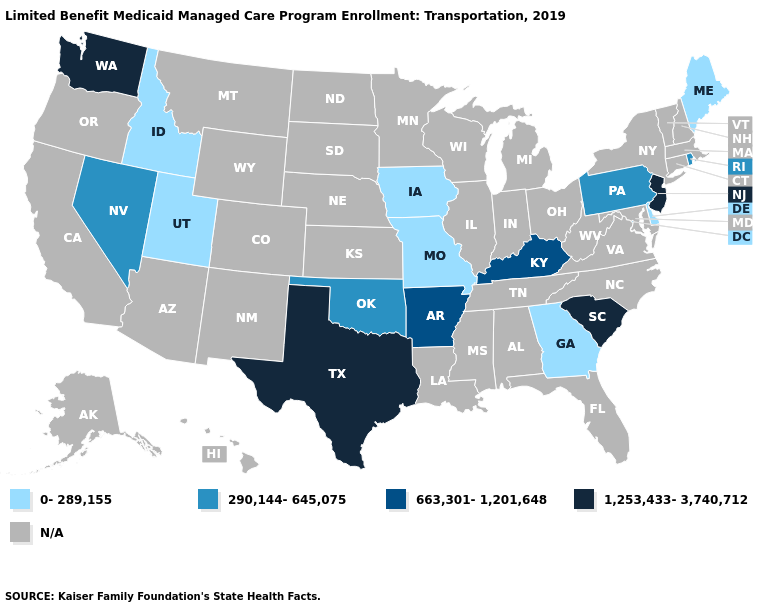Which states have the highest value in the USA?
Keep it brief. New Jersey, South Carolina, Texas, Washington. What is the value of Tennessee?
Keep it brief. N/A. Which states have the lowest value in the USA?
Keep it brief. Delaware, Georgia, Idaho, Iowa, Maine, Missouri, Utah. What is the value of New Mexico?
Be succinct. N/A. Is the legend a continuous bar?
Keep it brief. No. Name the states that have a value in the range N/A?
Short answer required. Alabama, Alaska, Arizona, California, Colorado, Connecticut, Florida, Hawaii, Illinois, Indiana, Kansas, Louisiana, Maryland, Massachusetts, Michigan, Minnesota, Mississippi, Montana, Nebraska, New Hampshire, New Mexico, New York, North Carolina, North Dakota, Ohio, Oregon, South Dakota, Tennessee, Vermont, Virginia, West Virginia, Wisconsin, Wyoming. Which states have the highest value in the USA?
Answer briefly. New Jersey, South Carolina, Texas, Washington. Which states have the highest value in the USA?
Keep it brief. New Jersey, South Carolina, Texas, Washington. What is the value of Iowa?
Give a very brief answer. 0-289,155. What is the value of Utah?
Keep it brief. 0-289,155. Name the states that have a value in the range 290,144-645,075?
Concise answer only. Nevada, Oklahoma, Pennsylvania, Rhode Island. 